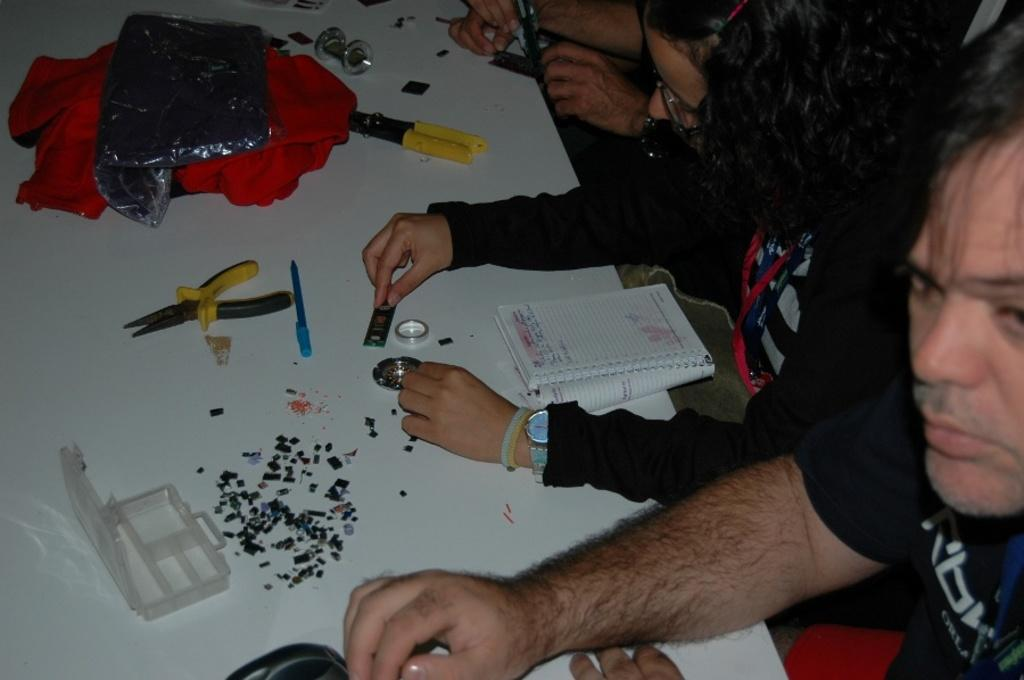How many people are in the image? There are people in the image. What is the color of the table in the image? There is a white table in the image. What items can be seen on the table? There is a book, a box, tools, and cloth on the table. Are there any objects on the table? Yes, there are objects on the table. What are the people holding in the image? Two people are holding objects in the image. What type of cabbage is being used to drain the power in the image? There is no cabbage or mention of draining power in the image. 